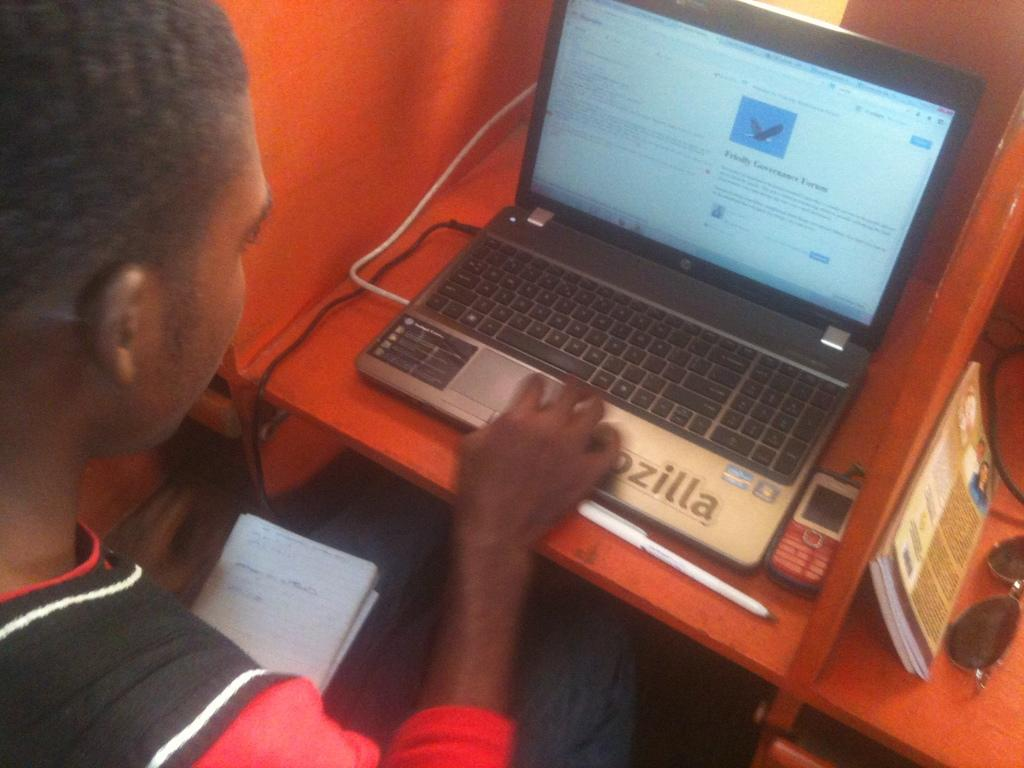<image>
Describe the image concisely. Person using a laptop that says "zilla" on the bottom. 